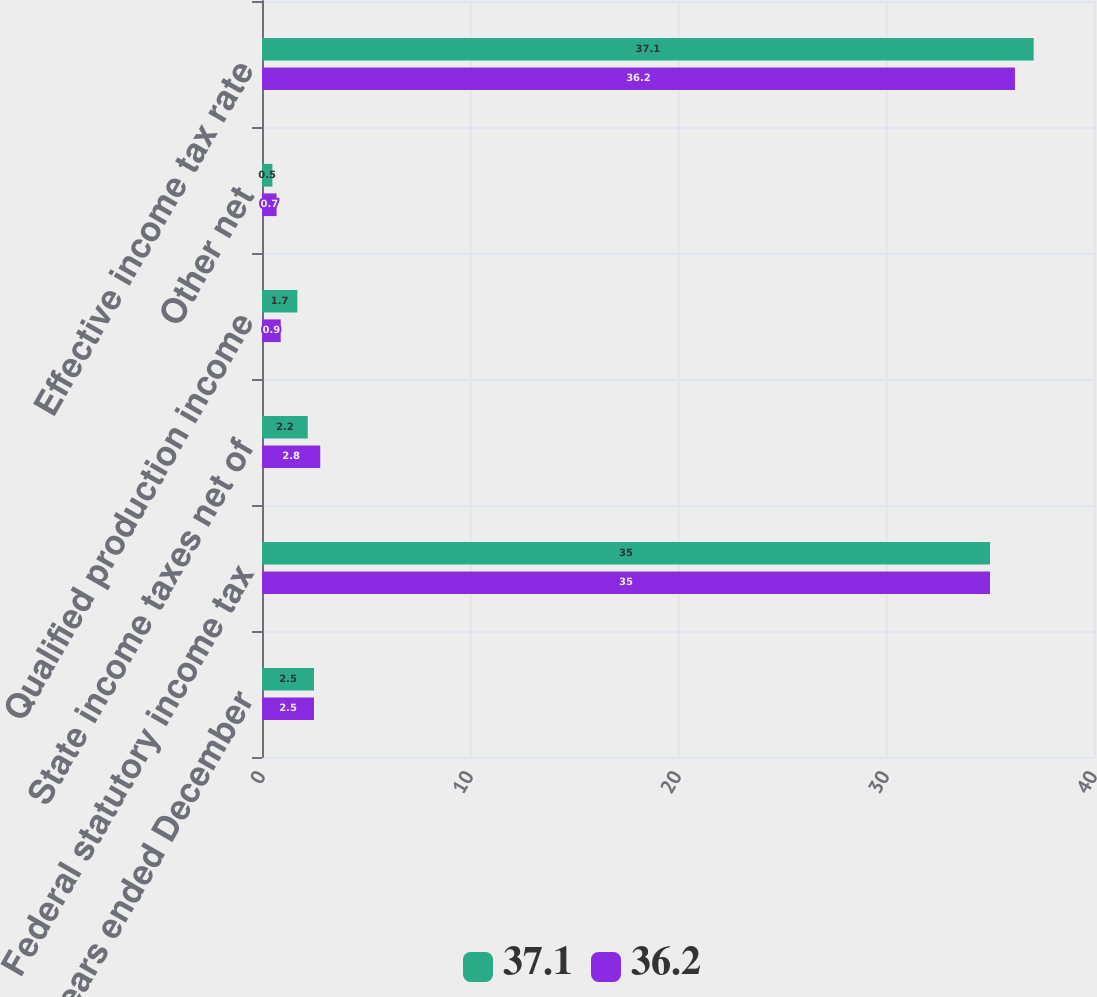Convert chart. <chart><loc_0><loc_0><loc_500><loc_500><stacked_bar_chart><ecel><fcel>For the years ended December<fcel>Federal statutory income tax<fcel>State income taxes net of<fcel>Qualified production income<fcel>Other net<fcel>Effective income tax rate<nl><fcel>37.1<fcel>2.5<fcel>35<fcel>2.2<fcel>1.7<fcel>0.5<fcel>37.1<nl><fcel>36.2<fcel>2.5<fcel>35<fcel>2.8<fcel>0.9<fcel>0.7<fcel>36.2<nl></chart> 